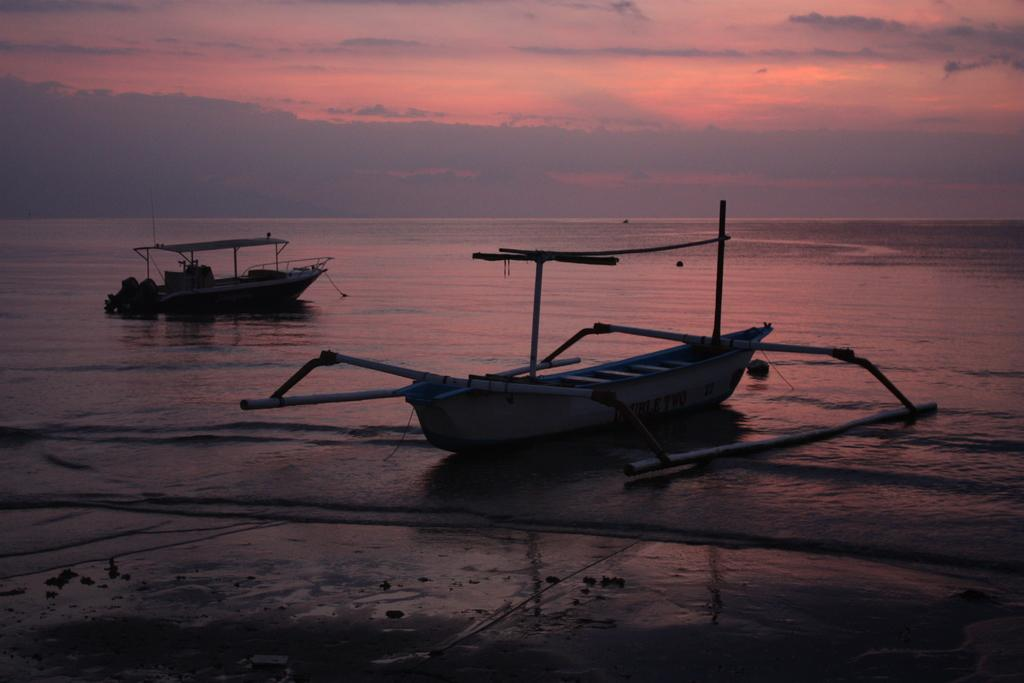How many boats are in the image? There are two boats in the image. Where are the boats located? The boats are on the water. What type of water body can be seen in the image? There is an ocean visible in the background of the image. What is visible at the top of the image? The sky is visible at the top of the image. What can be seen in the sky? Clouds are present in the sky. What is visible at the bottom of the image? There is a beach visible at the bottom of the image. How many cakes are being eaten by the girls on the beach in the image? There are no girls or cakes present in the image; it features two boats on the water with an ocean and beach in the background. 